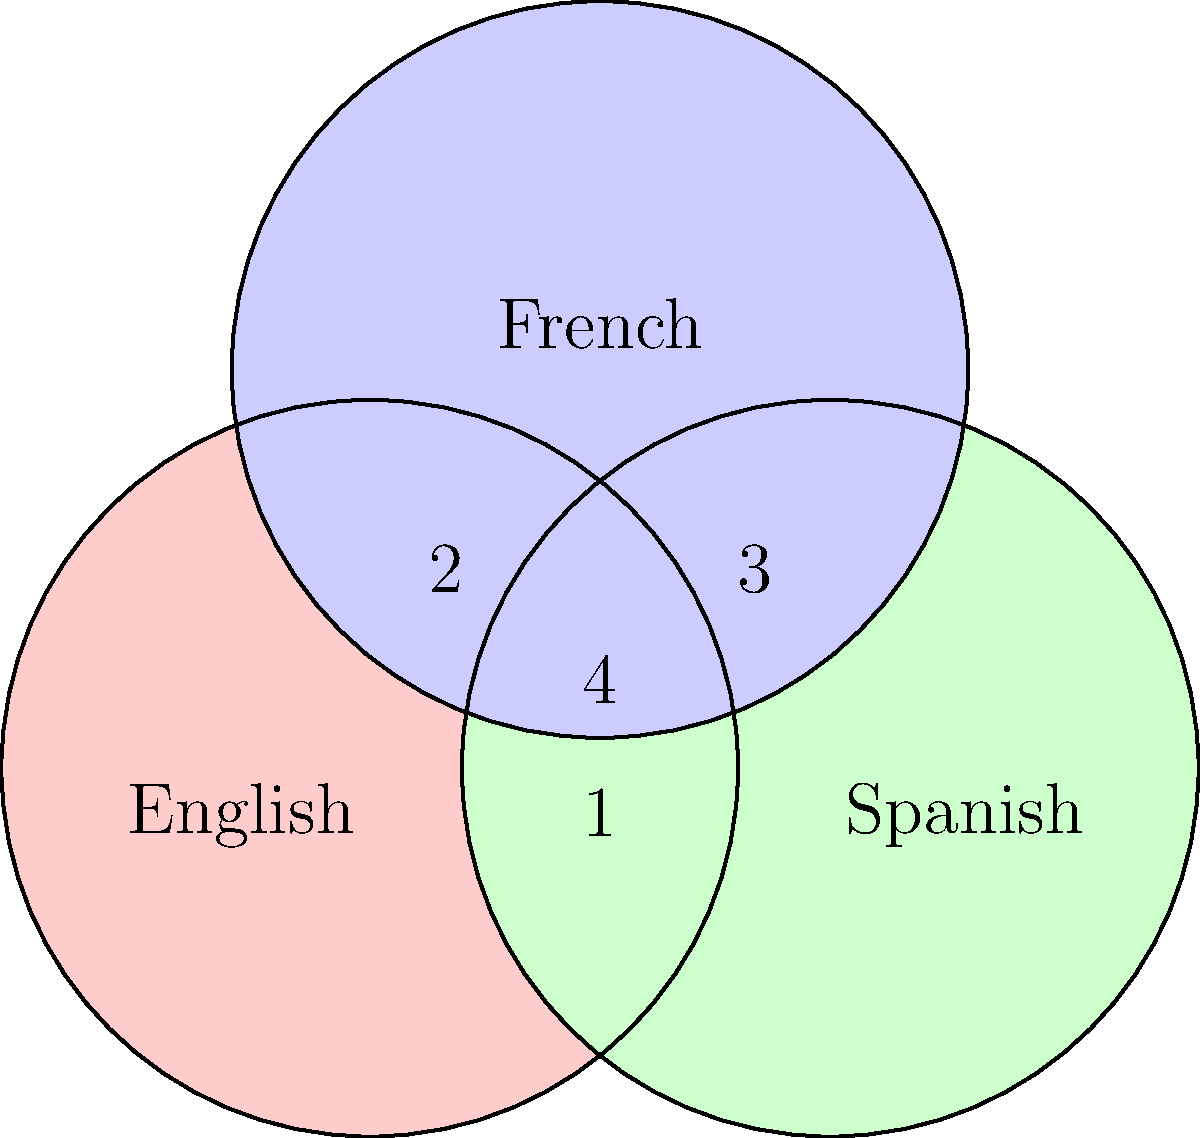In the Venn diagram representing semantic overlap between English, Spanish, and French, which area represents words or phrases that have equivalent meanings in all three languages but may require transcreation to maintain cultural relevance? To answer this question, let's analyze the Venn diagram step-by-step:

1. The diagram shows three overlapping circles representing English, Spanish, and French languages.

2. Each circle represents the semantic field of its respective language.

3. The overlapping areas represent shared semantic spaces between languages:
   - Area 1: Overlap between English and Spanish
   - Area 2: Overlap between English and French
   - Area 3: Overlap between Spanish and French
   - Area 4: Overlap among all three languages (English, Spanish, and French)

4. Area 4, at the center where all three circles intersect, represents concepts that have equivalent meanings in all three languages.

5. However, the question asks about words or phrases that may require transcreation to maintain cultural relevance. Transcreation involves adapting content to resonate with different cultural contexts while preserving the original intent, tone, and style.

6. Even though these words or phrases have equivalent meanings across all three languages (represented by Area 4), they may still need to be adapted to fit specific cultural nuances in each language.

7. Therefore, Area 4 is the correct answer, as it represents the semantic overlap where concepts exist in all three languages but may require cultural adaptation through transcreation.
Answer: Area 4 